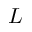Convert formula to latex. <formula><loc_0><loc_0><loc_500><loc_500>L</formula> 